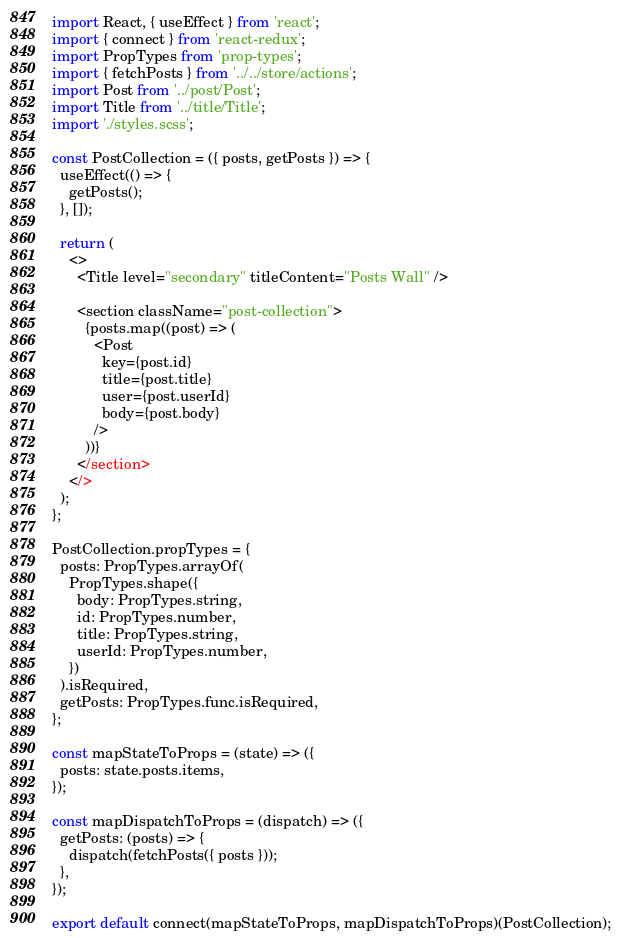<code> <loc_0><loc_0><loc_500><loc_500><_JavaScript_>import React, { useEffect } from 'react';
import { connect } from 'react-redux';
import PropTypes from 'prop-types';
import { fetchPosts } from '../../store/actions';
import Post from '../post/Post';
import Title from '../title/Title';
import './styles.scss';

const PostCollection = ({ posts, getPosts }) => {
  useEffect(() => {
    getPosts();
  }, []);

  return (
    <>
      <Title level="secondary" titleContent="Posts Wall" />

      <section className="post-collection">
        {posts.map((post) => (
          <Post
            key={post.id}
            title={post.title}
            user={post.userId}
            body={post.body}
          />
        ))}
      </section>
    </>
  );
};

PostCollection.propTypes = {
  posts: PropTypes.arrayOf(
    PropTypes.shape({
      body: PropTypes.string,
      id: PropTypes.number,
      title: PropTypes.string,
      userId: PropTypes.number,
    })
  ).isRequired,
  getPosts: PropTypes.func.isRequired,
};

const mapStateToProps = (state) => ({
  posts: state.posts.items,
});

const mapDispatchToProps = (dispatch) => ({
  getPosts: (posts) => {
    dispatch(fetchPosts({ posts }));
  },
});

export default connect(mapStateToProps, mapDispatchToProps)(PostCollection);
</code> 